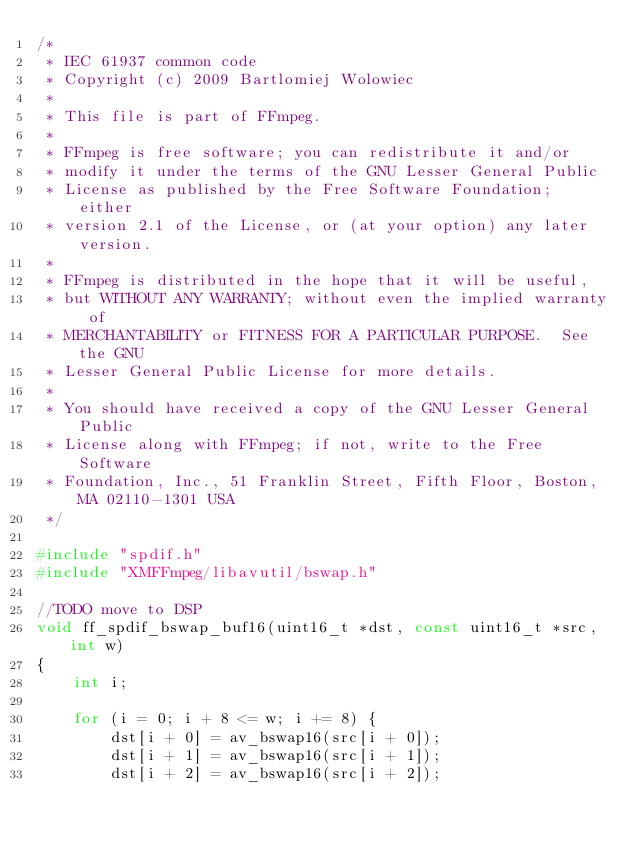Convert code to text. <code><loc_0><loc_0><loc_500><loc_500><_C++_>/*
 * IEC 61937 common code
 * Copyright (c) 2009 Bartlomiej Wolowiec
 *
 * This file is part of FFmpeg.
 *
 * FFmpeg is free software; you can redistribute it and/or
 * modify it under the terms of the GNU Lesser General Public
 * License as published by the Free Software Foundation; either
 * version 2.1 of the License, or (at your option) any later version.
 *
 * FFmpeg is distributed in the hope that it will be useful,
 * but WITHOUT ANY WARRANTY; without even the implied warranty of
 * MERCHANTABILITY or FITNESS FOR A PARTICULAR PURPOSE.  See the GNU
 * Lesser General Public License for more details.
 *
 * You should have received a copy of the GNU Lesser General Public
 * License along with FFmpeg; if not, write to the Free Software
 * Foundation, Inc., 51 Franklin Street, Fifth Floor, Boston, MA 02110-1301 USA
 */

#include "spdif.h"
#include "XMFFmpeg/libavutil/bswap.h"

//TODO move to DSP
void ff_spdif_bswap_buf16(uint16_t *dst, const uint16_t *src, int w)
{
    int i;

    for (i = 0; i + 8 <= w; i += 8) {
        dst[i + 0] = av_bswap16(src[i + 0]);
        dst[i + 1] = av_bswap16(src[i + 1]);
        dst[i + 2] = av_bswap16(src[i + 2]);</code> 